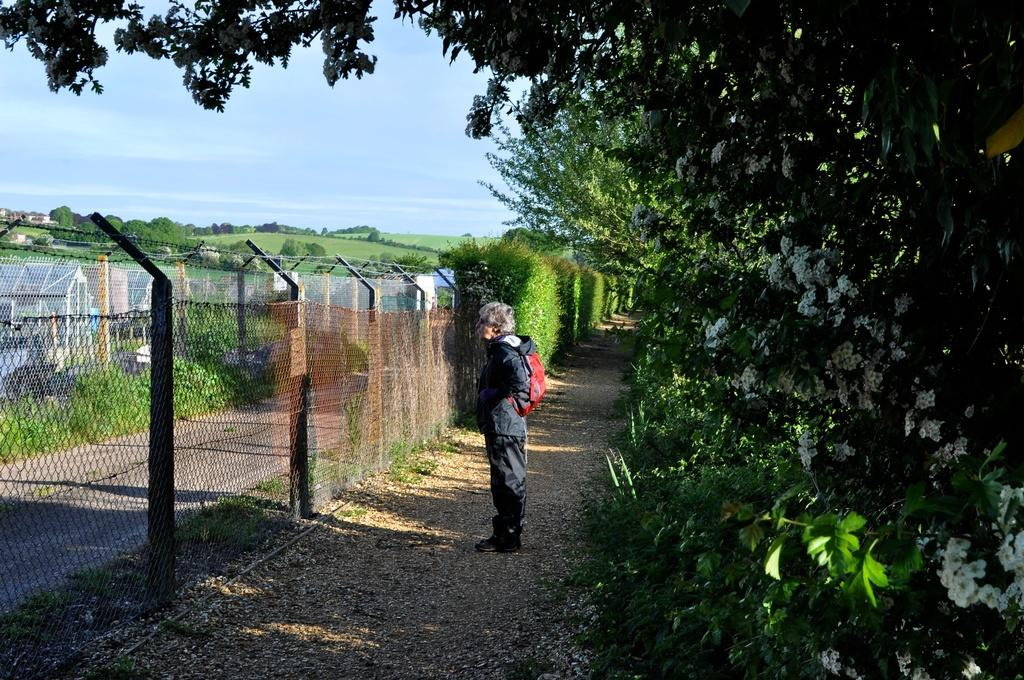What is the main subject of the image? There is a person standing in the image. What is in front of the person? The person is in front of a fence. What is behind the fence? There is a road behind the fence. What can be seen behind the person? There are trees behind the person. What type of natural setting is visible in the image? There is a grassland with trees beside a lake in the image. Can you see any jellyfish in the lake in the image? There is no lake visible in the image, only a grassland with trees beside it. What type of watch is the person wearing in the image? There is no watch visible on the person in the image. 